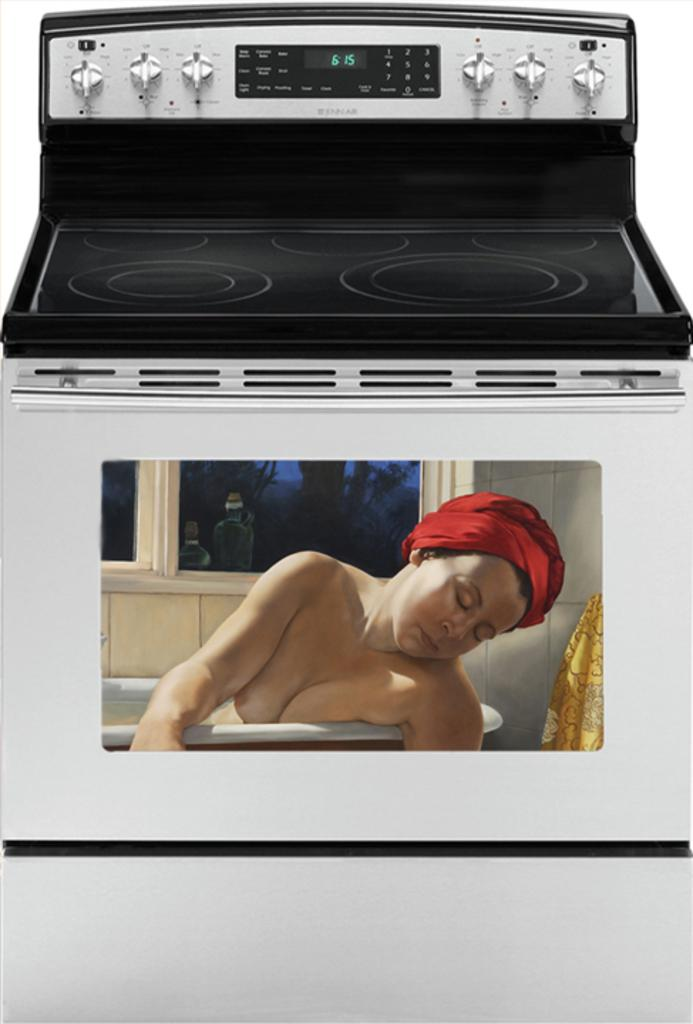What is the main subject of the image? The main subject of the image is a picture of a person. Where is the picture of the person located? The picture of the person is on an oven. What type of sugar is being used to make the elbow in the image? There is no sugar or elbow present in the image; it features a picture of a person on an oven. What type of quiver is visible in the image? There is no quiver present in the image. 